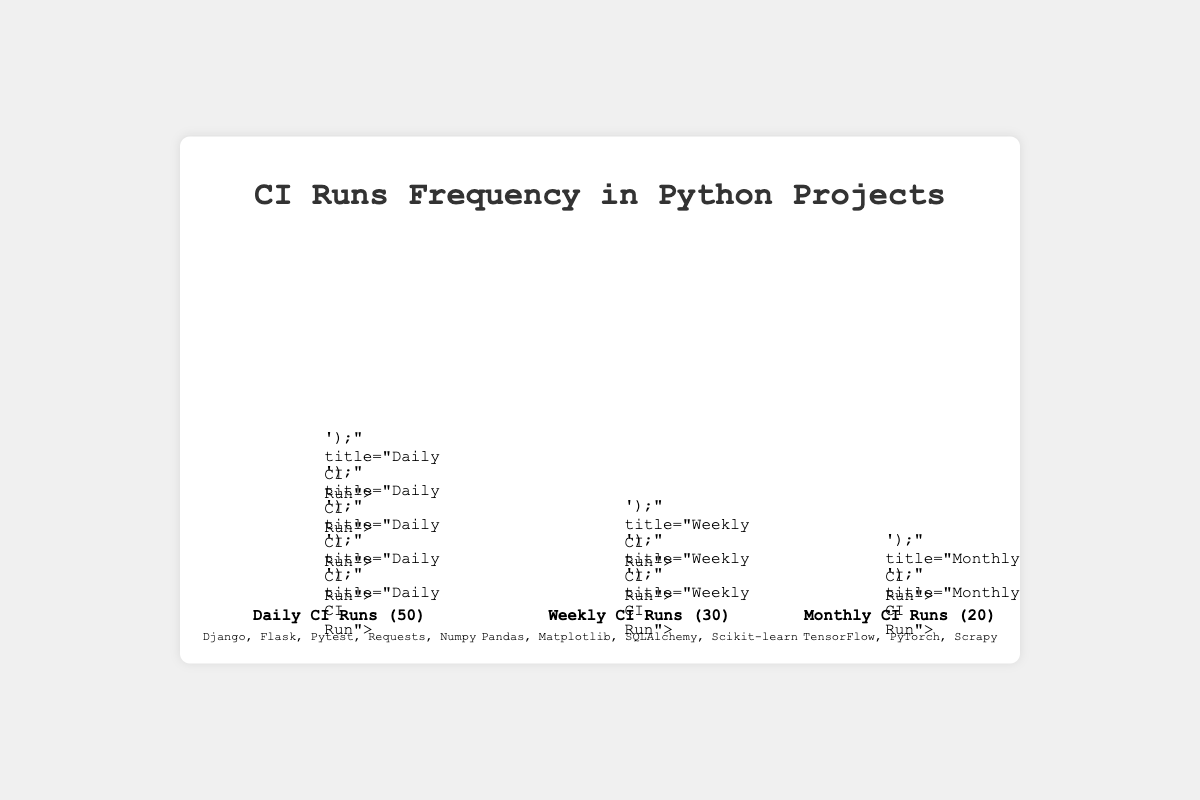What is the title of the figure? The title is located at the top center of the plot. The text reads "CI Runs Frequency in Python Projects".
Answer: CI Runs Frequency in Python Projects How many total projects run CI daily? The "Daily CI Runs" category includes a count of 50, indicating the total number of daily CI runs. However, the exact projects are listed as 5: Django, Flask, Pytest, Requests, and Numpy.
Answer: 50 Which category has the least number of CI runs? By observing the labels and counts at the bottom of each category, "Monthly CI Runs" has the smallest count of 20.
Answer: Monthly CI Runs What is the combined number of weekly and monthly CI runs? The number of weekly CI runs is 30, and monthly CI runs is 20. Summing these two values gives 30 + 20 = 50.
Answer: 50 How does the count of daily CI runs compare to the count of monthly CI runs? The "Daily CI Runs" category has a count of 50, while the "Monthly CI Runs" category has 20. 50 is greater than 20.
Answer: Daily CI Runs have more counts Which projects are represented in weekly CI runs? The "Weekly CI Runs" category shows a list under the icons with the projects: Pandas, Matplotlib, SQLAlchemy, and Scikit-learn.
Answer: Pandas, Matplotlib, SQLAlchemy, Scikit-learn How many unique projects are listed in all categories combined? Counting each unique project from all categories: Django, Flask, Pytest, Requests, Numpy, Pandas, Matplotlib, SQLAlchemy, Scikit-learn, TensorFlow, PyTorch, Scrapy. There are 12 unique projects in total.
Answer: 12 What is the average number of CI runs per category? Summing the counts of each category: 50 (Daily) + 30 (Weekly) + 20 (Monthly) = 100. There are 3 categories, so the average is 100 / 3 ≈ 33.33.
Answer: 33.33 Which projects are run on a daily basis? The "Daily CI Runs" category lists the projects: Django, Flask, Pytest, Requests, and Numpy.
Answer: Django, Flask, Pytest, Requests, Numpy Which category has more projects, Daily or Monthly CI runs? The "Daily CI Runs" lists 5 projects, whereas the "Monthly CI Runs" lists 3 projects. Therefore, the Daily CI Runs category has more projects.
Answer: Daily CI Runs 